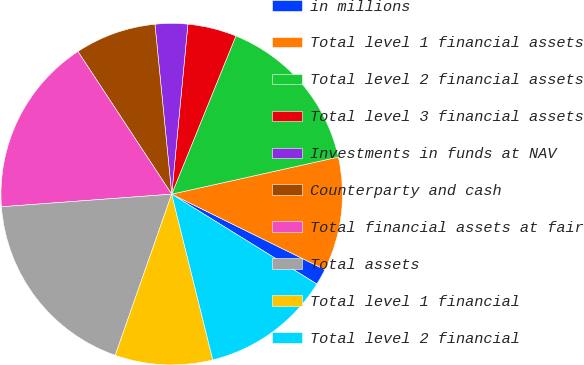Convert chart. <chart><loc_0><loc_0><loc_500><loc_500><pie_chart><fcel>in millions<fcel>Total level 1 financial assets<fcel>Total level 2 financial assets<fcel>Total level 3 financial assets<fcel>Investments in funds at NAV<fcel>Counterparty and cash<fcel>Total financial assets at fair<fcel>Total assets<fcel>Total level 1 financial<fcel>Total level 2 financial<nl><fcel>1.54%<fcel>10.77%<fcel>15.38%<fcel>4.62%<fcel>3.08%<fcel>7.69%<fcel>16.92%<fcel>18.46%<fcel>9.23%<fcel>12.31%<nl></chart> 